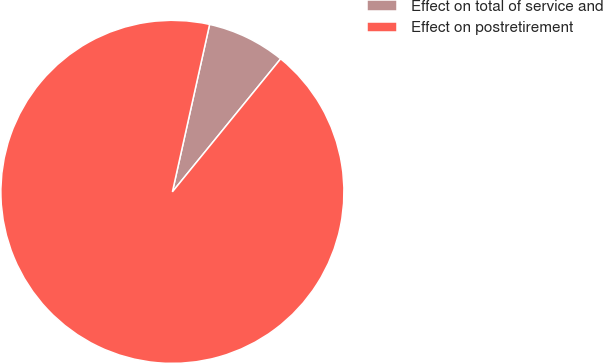Convert chart. <chart><loc_0><loc_0><loc_500><loc_500><pie_chart><fcel>Effect on total of service and<fcel>Effect on postretirement<nl><fcel>7.39%<fcel>92.61%<nl></chart> 